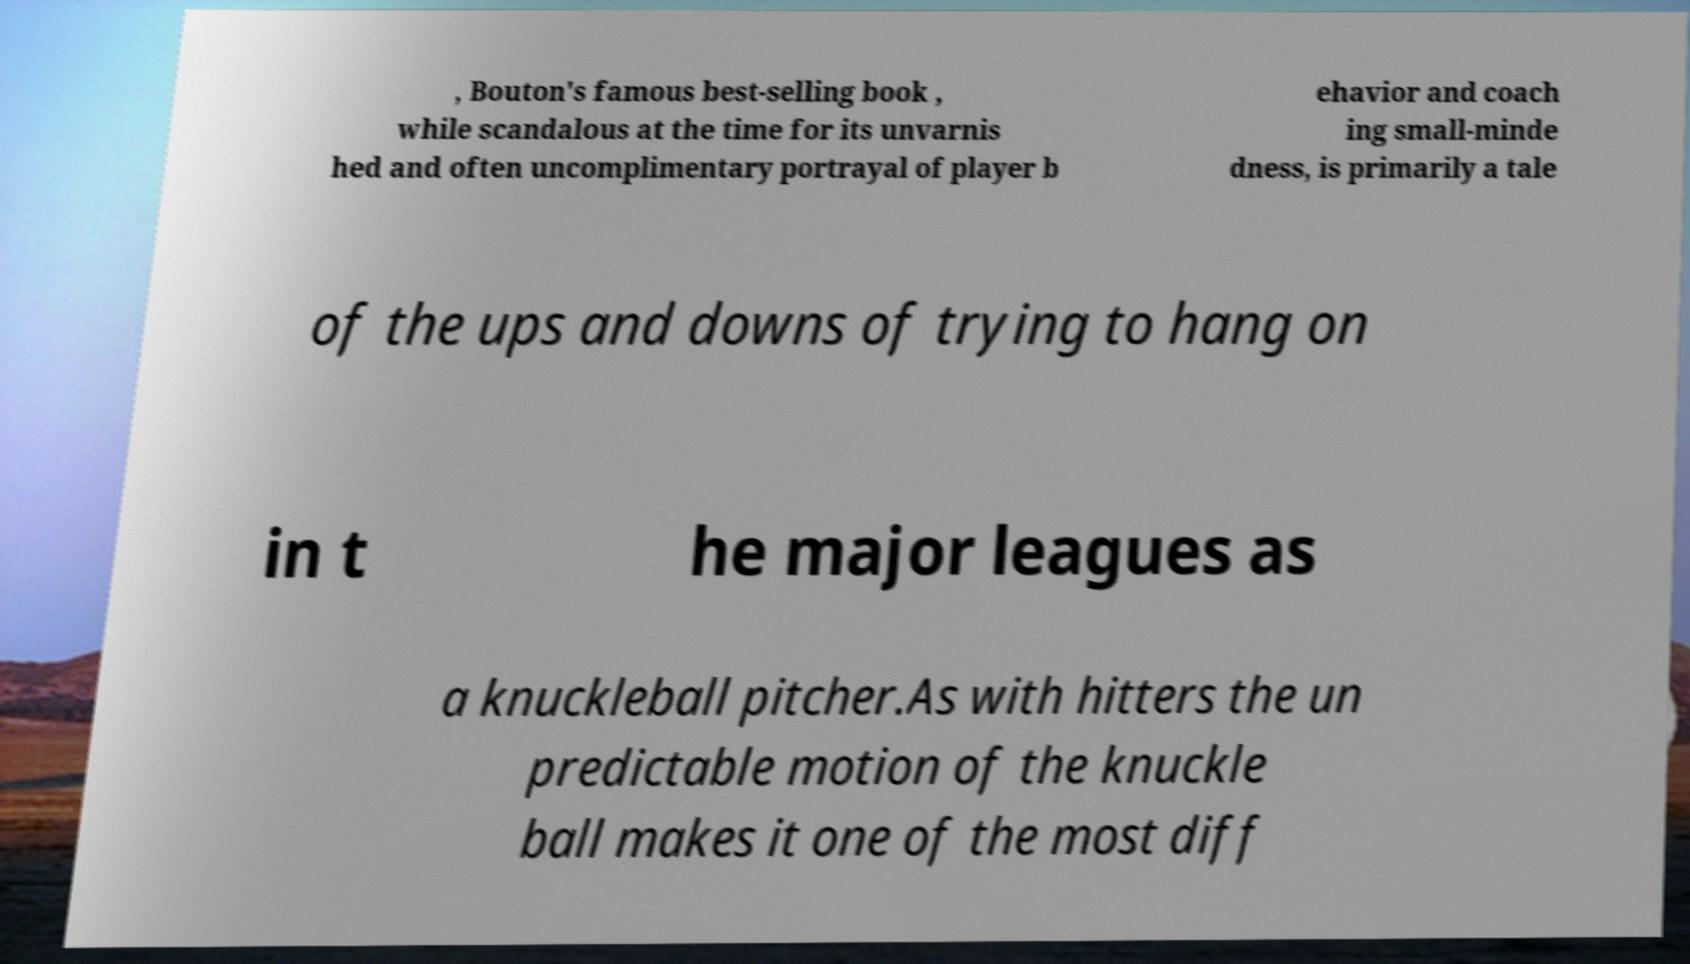For documentation purposes, I need the text within this image transcribed. Could you provide that? , Bouton's famous best-selling book , while scandalous at the time for its unvarnis hed and often uncomplimentary portrayal of player b ehavior and coach ing small-minde dness, is primarily a tale of the ups and downs of trying to hang on in t he major leagues as a knuckleball pitcher.As with hitters the un predictable motion of the knuckle ball makes it one of the most diff 